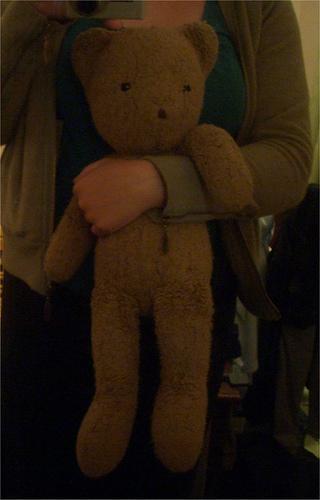How many people are holding a teddy?
Give a very brief answer. 1. How many people are in the picture?
Give a very brief answer. 1. 